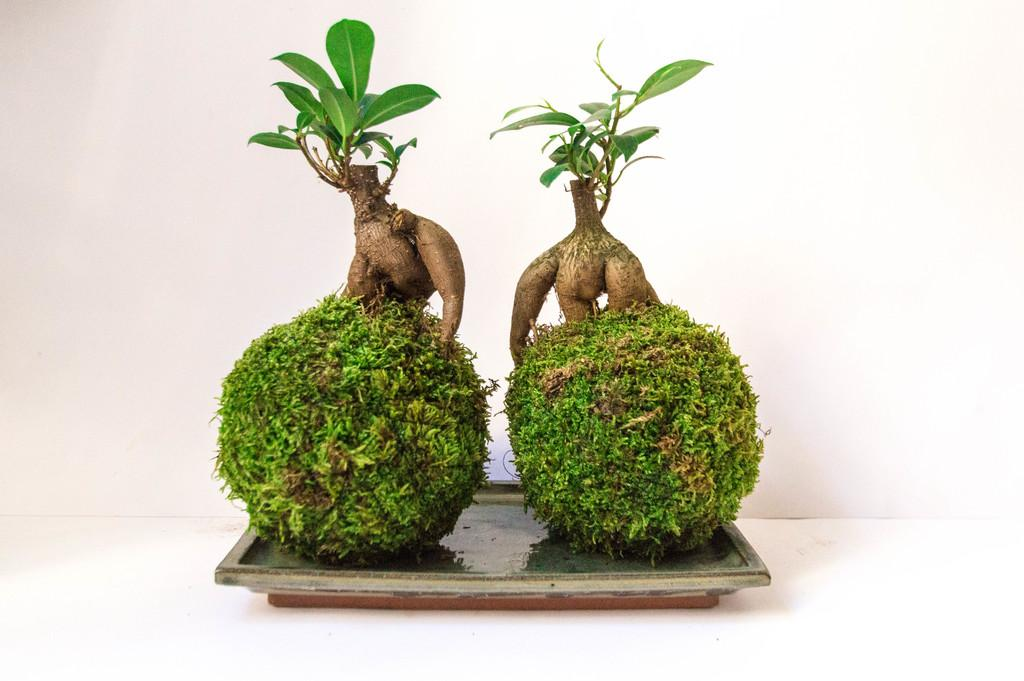How many plants are in the image? There are two plants in the image. What are the main features of the plants? The plants have leaves, stems, and branches. Where are the plants located? The plants are in a pot. What can be seen in the background of the image? There is a wall in the background of the image. What is the color of the surface at the bottom of the image? The surface at the bottom of the image is white. What hobbies do the plants enjoy in the image? Plants do not have hobbies, as they are living organisms and not capable of engaging in hobbies. 